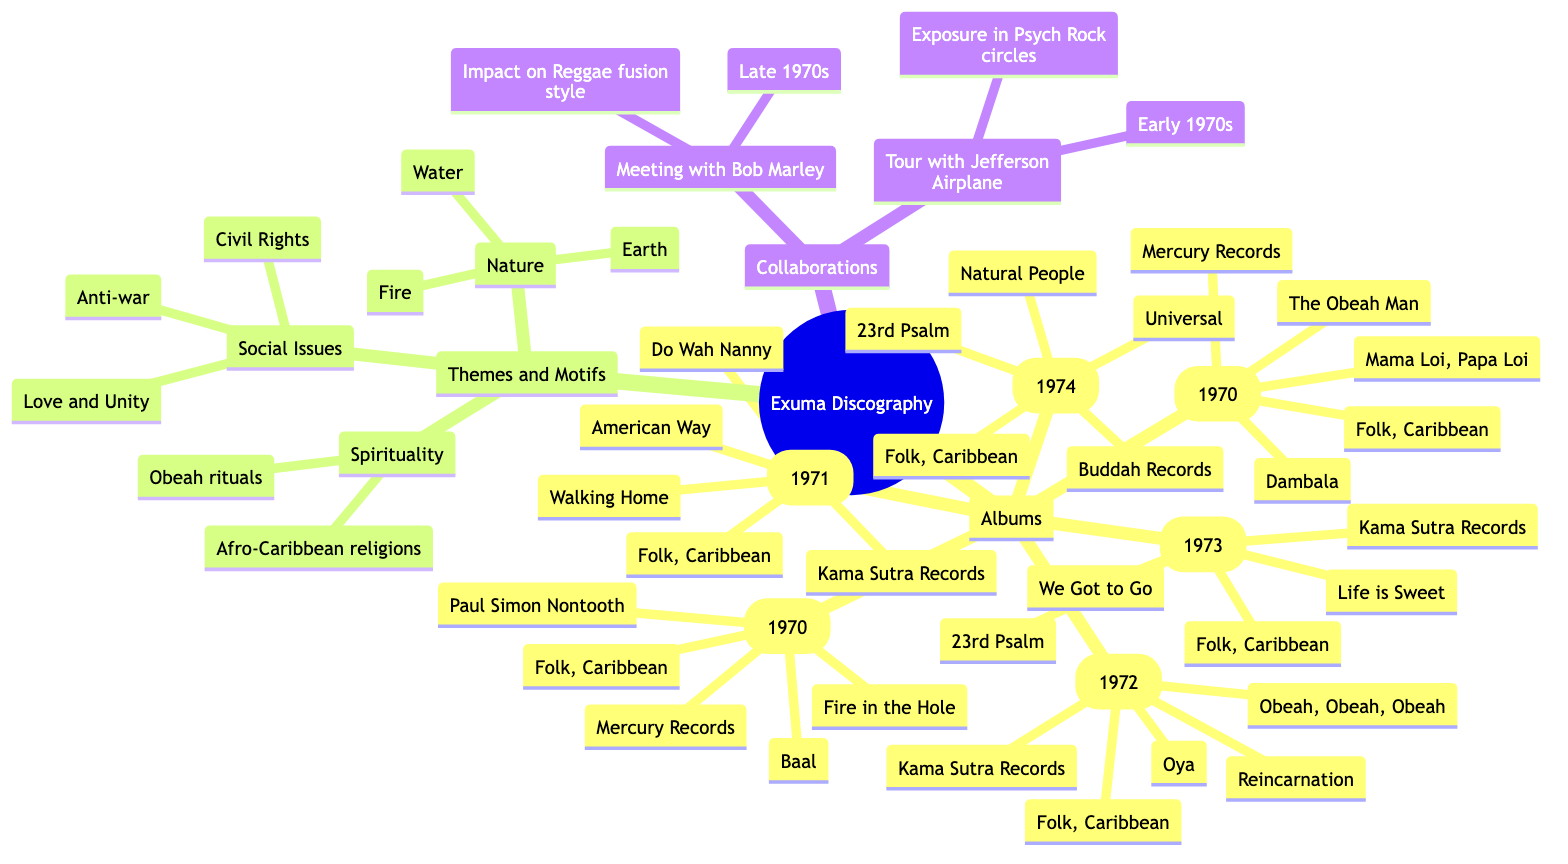What are the key tracks of "Exuma II (1970)"? The key tracks for "Exuma II (1970)" are listed directly under that album node in the diagram. They include "Paul Simon Nontooth," "Baal," and "Fire in the Hole."
Answer: Paul Simon Nontooth, Baal, Fire in the Hole Which album was released under Buddah Records? By examining the 'Albums' section, you can see that "Universal (1974)" is the only album listed with the label Buddah Records.
Answer: Universal (1974) How many albums did Exuma release in 1970? The diagram shows two albums released in 1970 under the 'Albums' section: "Exuma I (1970)" and "Exuma II (1970)." This can be counted directly from the list.
Answer: 2 What are the themes connected to social issues in Exuma's work? The diagram specifies "Social Issues" under the 'Themes and Motifs' section, detailing "Anti-war," "Civil Rights," and "Love and Unity," which are directly listed.
Answer: Anti-war, Civil Rights, Love and Unity Which collaborator's meeting is noted for impacting Reggae fusion style? Under the 'Collaborations' section, the meeting with Bob Marley is highlighted, stating its significance for impacting the Reggae fusion style.
Answer: Bob Marley What genre do all albums listed under Exuma's discography belong to? Looking through the 'Albums' section, each album explicitly states its genre as "Folk, Caribbean" which is consistent across all entries.
Answer: Folk, Caribbean What is the significance of the tour with Jefferson Airplane? This information is found under the 'Collaborations' section, indicating that the tour with Jefferson Airplane brought exposure in Psych Rock circles.
Answer: Exposure in Psych Rock circles Which key track appears in both "Life (1973)" and "Universal (1974)"? Checking the 'KeyTracks' lists for both albums, "23rd Psalm" is listed as a key track under both "Life (1973)" and "Universal (1974)."
Answer: 23rd Psalm 